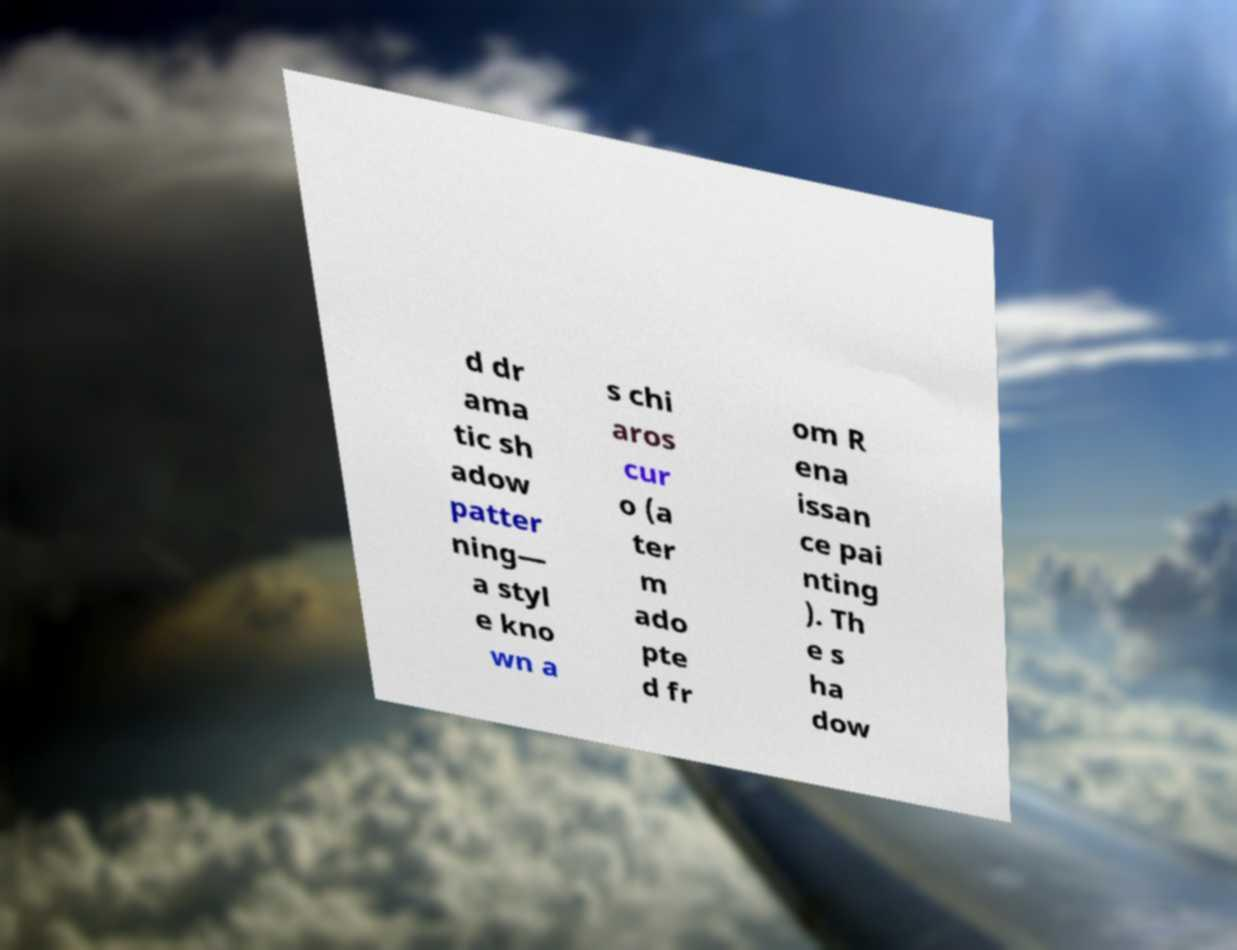For documentation purposes, I need the text within this image transcribed. Could you provide that? d dr ama tic sh adow patter ning— a styl e kno wn a s chi aros cur o (a ter m ado pte d fr om R ena issan ce pai nting ). Th e s ha dow 